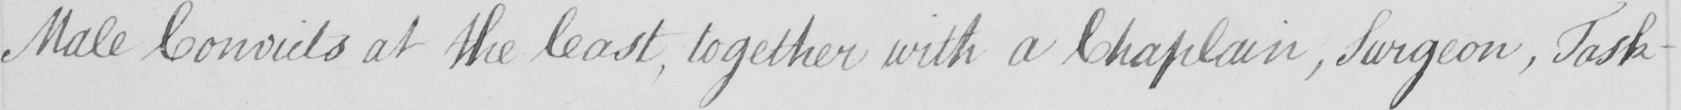Transcribe the text shown in this historical manuscript line. Male Convicts at the least , together with a Chaplain , Surgeon , Task- 